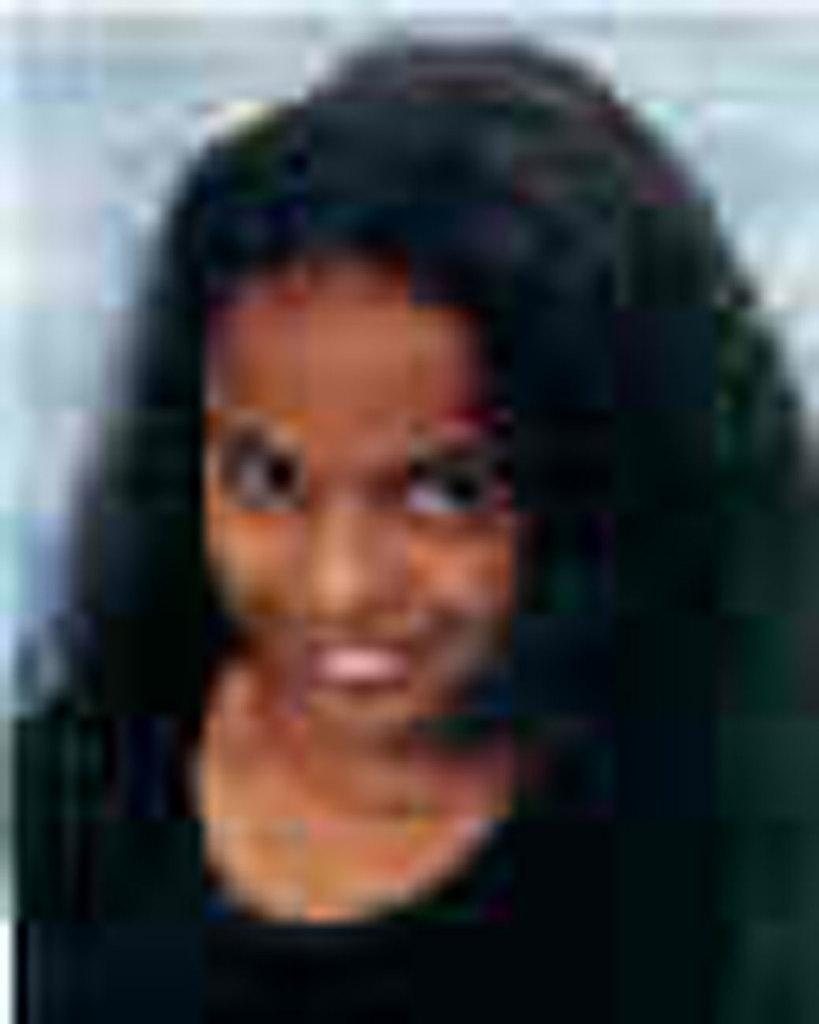Who is the main subject in the image? There is a woman in the image. What is the woman wearing? The woman is wearing a black top. Can you describe the background of the image? The background of the image is blurry. What type of songs is the woman singing in the image? There is no indication in the image that the woman is singing any songs, so it cannot be determined from the picture. 